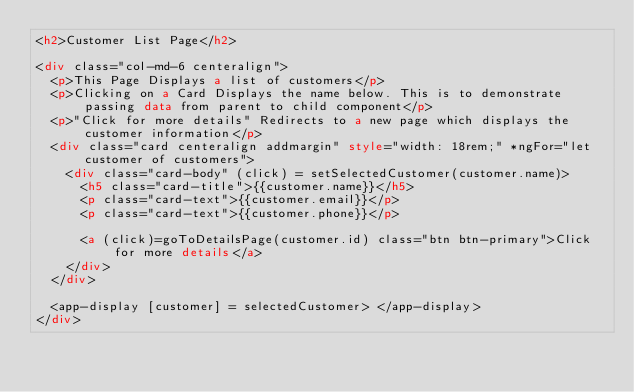<code> <loc_0><loc_0><loc_500><loc_500><_HTML_><h2>Customer List Page</h2>

<div class="col-md-6 centeralign">
  <p>This Page Displays a list of customers</p>
  <p>Clicking on a Card Displays the name below. This is to demonstrate passing data from parent to child component</p>
  <p>"Click for more details" Redirects to a new page which displays the customer information</p>
  <div class="card centeralign addmargin" style="width: 18rem;" *ngFor="let customer of customers">
    <div class="card-body" (click) = setSelectedCustomer(customer.name)>
      <h5 class="card-title">{{customer.name}}</h5>
      <p class="card-text">{{customer.email}}</p>
      <p class="card-text">{{customer.phone}}</p>

      <a (click)=goToDetailsPage(customer.id) class="btn btn-primary">Click for more details</a>
    </div>
  </div>

  <app-display [customer] = selectedCustomer> </app-display>
</div>
</code> 